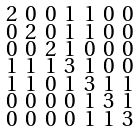Convert formula to latex. <formula><loc_0><loc_0><loc_500><loc_500>\begin{smallmatrix} 2 & 0 & 0 & 1 & 1 & 0 & 0 \\ 0 & 2 & 0 & 1 & 1 & 0 & 0 \\ 0 & 0 & 2 & 1 & 0 & 0 & 0 \\ 1 & 1 & 1 & 3 & 1 & 0 & 0 \\ 1 & 1 & 0 & 1 & 3 & 1 & 1 \\ 0 & 0 & 0 & 0 & 1 & 3 & 1 \\ 0 & 0 & 0 & 0 & 1 & 1 & 3 \end{smallmatrix}</formula> 